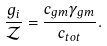Convert formula to latex. <formula><loc_0><loc_0><loc_500><loc_500>\frac { g _ { i } } { \mathcal { Z } } = \frac { c _ { g m } \gamma _ { g m } } { c _ { t o t } } .</formula> 